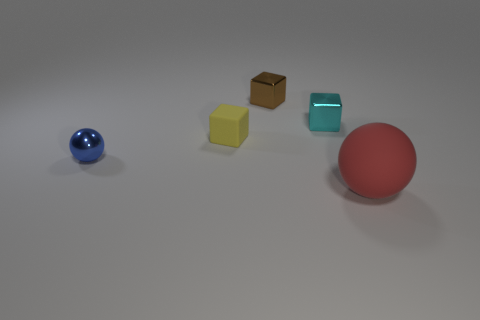Do the ball on the right side of the tiny cyan metal block and the small rubber thing have the same color?
Provide a short and direct response. No. The matte thing to the left of the object that is in front of the blue object is what shape?
Your response must be concise. Cube. Is there a red metal cylinder of the same size as the red ball?
Provide a short and direct response. No. Are there fewer tiny yellow things than small purple cylinders?
Your answer should be very brief. No. There is a rubber object that is behind the object in front of the shiny thing on the left side of the yellow rubber block; what shape is it?
Offer a terse response. Cube. How many objects are tiny metallic things in front of the small brown metallic block or objects to the left of the big red ball?
Offer a very short reply. 4. There is a tiny brown metal object; are there any tiny metal objects in front of it?
Your response must be concise. Yes. How many objects are small blocks to the left of the cyan metal thing or large yellow rubber cylinders?
Keep it short and to the point. 2. What number of cyan objects are either tiny shiny spheres or balls?
Your response must be concise. 0. Are there fewer red objects that are behind the yellow cube than tiny purple metallic objects?
Make the answer very short. No. 